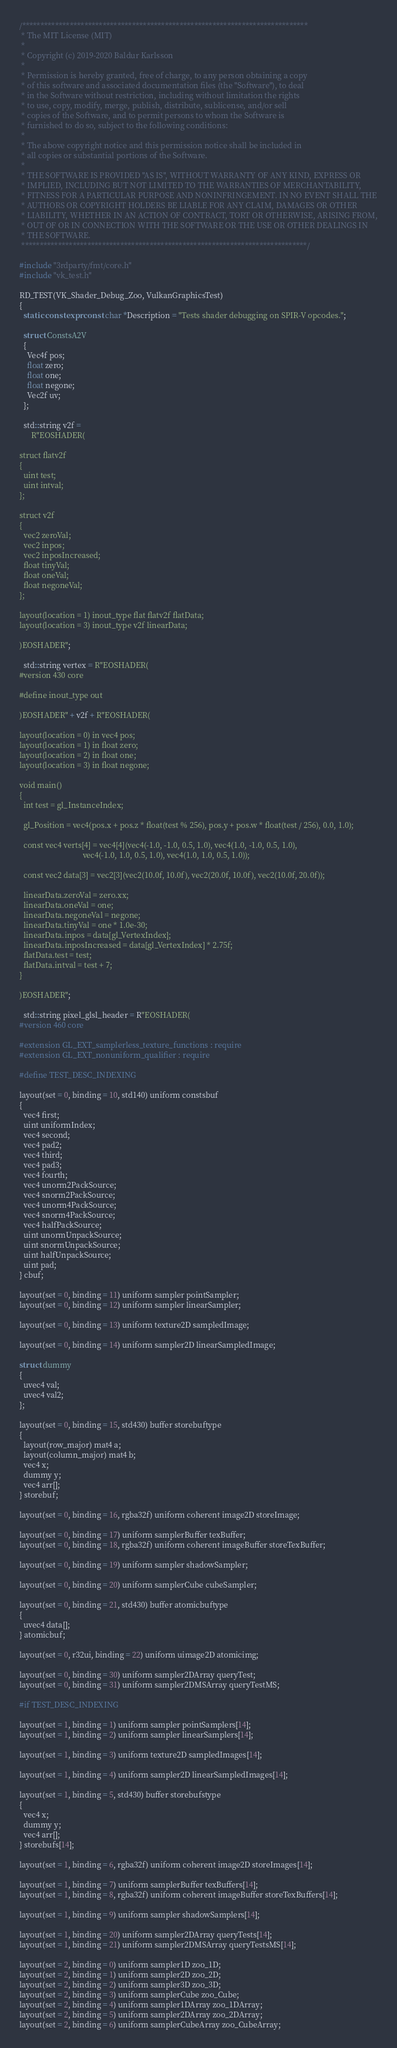Convert code to text. <code><loc_0><loc_0><loc_500><loc_500><_C++_>/******************************************************************************
 * The MIT License (MIT)
 *
 * Copyright (c) 2019-2020 Baldur Karlsson
 *
 * Permission is hereby granted, free of charge, to any person obtaining a copy
 * of this software and associated documentation files (the "Software"), to deal
 * in the Software without restriction, including without limitation the rights
 * to use, copy, modify, merge, publish, distribute, sublicense, and/or sell
 * copies of the Software, and to permit persons to whom the Software is
 * furnished to do so, subject to the following conditions:
 *
 * The above copyright notice and this permission notice shall be included in
 * all copies or substantial portions of the Software.
 *
 * THE SOFTWARE IS PROVIDED "AS IS", WITHOUT WARRANTY OF ANY KIND, EXPRESS OR
 * IMPLIED, INCLUDING BUT NOT LIMITED TO THE WARRANTIES OF MERCHANTABILITY,
 * FITNESS FOR A PARTICULAR PURPOSE AND NONINFRINGEMENT. IN NO EVENT SHALL THE
 * AUTHORS OR COPYRIGHT HOLDERS BE LIABLE FOR ANY CLAIM, DAMAGES OR OTHER
 * LIABILITY, WHETHER IN AN ACTION OF CONTRACT, TORT OR OTHERWISE, ARISING FROM,
 * OUT OF OR IN CONNECTION WITH THE SOFTWARE OR THE USE OR OTHER DEALINGS IN
 * THE SOFTWARE.
 ******************************************************************************/

#include "3rdparty/fmt/core.h"
#include "vk_test.h"

RD_TEST(VK_Shader_Debug_Zoo, VulkanGraphicsTest)
{
  static constexpr const char *Description = "Tests shader debugging on SPIR-V opcodes.";

  struct ConstsA2V
  {
    Vec4f pos;
    float zero;
    float one;
    float negone;
    Vec2f uv;
  };

  std::string v2f =
      R"EOSHADER(

struct flatv2f
{
  uint test;
  uint intval;
};

struct v2f
{
  vec2 zeroVal;
  vec2 inpos;
  vec2 inposIncreased;
  float tinyVal;
  float oneVal;
  float negoneVal;
};

layout(location = 1) inout_type flat flatv2f flatData;
layout(location = 3) inout_type v2f linearData;

)EOSHADER";

  std::string vertex = R"EOSHADER(
#version 430 core

#define inout_type out

)EOSHADER" + v2f + R"EOSHADER(

layout(location = 0) in vec4 pos;
layout(location = 1) in float zero;
layout(location = 2) in float one;
layout(location = 3) in float negone;

void main()
{
  int test = gl_InstanceIndex;
 
  gl_Position = vec4(pos.x + pos.z * float(test % 256), pos.y + pos.w * float(test / 256), 0.0, 1.0);

  const vec4 verts[4] = vec4[4](vec4(-1.0, -1.0, 0.5, 1.0), vec4(1.0, -1.0, 0.5, 1.0),
                                vec4(-1.0, 1.0, 0.5, 1.0), vec4(1.0, 1.0, 0.5, 1.0));

  const vec2 data[3] = vec2[3](vec2(10.0f, 10.0f), vec2(20.0f, 10.0f), vec2(10.0f, 20.0f));

  linearData.zeroVal = zero.xx;
  linearData.oneVal = one;
  linearData.negoneVal = negone;
  linearData.tinyVal = one * 1.0e-30;
  linearData.inpos = data[gl_VertexIndex];
  linearData.inposIncreased = data[gl_VertexIndex] * 2.75f;
  flatData.test = test;
  flatData.intval = test + 7;
}

)EOSHADER";

  std::string pixel_glsl_header = R"EOSHADER(
#version 460 core

#extension GL_EXT_samplerless_texture_functions : require
#extension GL_EXT_nonuniform_qualifier : require

#define TEST_DESC_INDEXING  

layout(set = 0, binding = 10, std140) uniform constsbuf
{
  vec4 first;
  uint uniformIndex;
  vec4 second;
  vec4 pad2;
  vec4 third;
  vec4 pad3;
  vec4 fourth;
  vec4 unorm2PackSource;
  vec4 snorm2PackSource;
  vec4 unorm4PackSource;
  vec4 snorm4PackSource;
  vec4 halfPackSource;
  uint unormUnpackSource;
  uint snormUnpackSource;
  uint halfUnpackSource;
  uint pad;
} cbuf;

layout(set = 0, binding = 11) uniform sampler pointSampler;
layout(set = 0, binding = 12) uniform sampler linearSampler;

layout(set = 0, binding = 13) uniform texture2D sampledImage;

layout(set = 0, binding = 14) uniform sampler2D linearSampledImage;

struct dummy
{
  uvec4 val;
  uvec4 val2;
};

layout(set = 0, binding = 15, std430) buffer storebuftype
{
  layout(row_major) mat4 a;
  layout(column_major) mat4 b;
  vec4 x;
  dummy y;
  vec4 arr[];
} storebuf;

layout(set = 0, binding = 16, rgba32f) uniform coherent image2D storeImage;

layout(set = 0, binding = 17) uniform samplerBuffer texBuffer;
layout(set = 0, binding = 18, rgba32f) uniform coherent imageBuffer storeTexBuffer;

layout(set = 0, binding = 19) uniform sampler shadowSampler;

layout(set = 0, binding = 20) uniform samplerCube cubeSampler;

layout(set = 0, binding = 21, std430) buffer atomicbuftype
{
  uvec4 data[];
} atomicbuf;

layout(set = 0, r32ui, binding = 22) uniform uimage2D atomicimg;

layout(set = 0, binding = 30) uniform sampler2DArray queryTest;
layout(set = 0, binding = 31) uniform sampler2DMSArray queryTestMS;

#if TEST_DESC_INDEXING

layout(set = 1, binding = 1) uniform sampler pointSamplers[14];
layout(set = 1, binding = 2) uniform sampler linearSamplers[14];

layout(set = 1, binding = 3) uniform texture2D sampledImages[14];

layout(set = 1, binding = 4) uniform sampler2D linearSampledImages[14];

layout(set = 1, binding = 5, std430) buffer storebufstype
{
  vec4 x;
  dummy y;
  vec4 arr[];
} storebufs[14];

layout(set = 1, binding = 6, rgba32f) uniform coherent image2D storeImages[14];

layout(set = 1, binding = 7) uniform samplerBuffer texBuffers[14];
layout(set = 1, binding = 8, rgba32f) uniform coherent imageBuffer storeTexBuffers[14];

layout(set = 1, binding = 9) uniform sampler shadowSamplers[14];

layout(set = 1, binding = 20) uniform sampler2DArray queryTests[14];
layout(set = 1, binding = 21) uniform sampler2DMSArray queryTestsMS[14];

layout(set = 2, binding = 0) uniform sampler1D zoo_1D;
layout(set = 2, binding = 1) uniform sampler2D zoo_2D;
layout(set = 2, binding = 2) uniform sampler3D zoo_3D;
layout(set = 2, binding = 3) uniform samplerCube zoo_Cube;
layout(set = 2, binding = 4) uniform sampler1DArray zoo_1DArray;
layout(set = 2, binding = 5) uniform sampler2DArray zoo_2DArray;
layout(set = 2, binding = 6) uniform samplerCubeArray zoo_CubeArray;</code> 